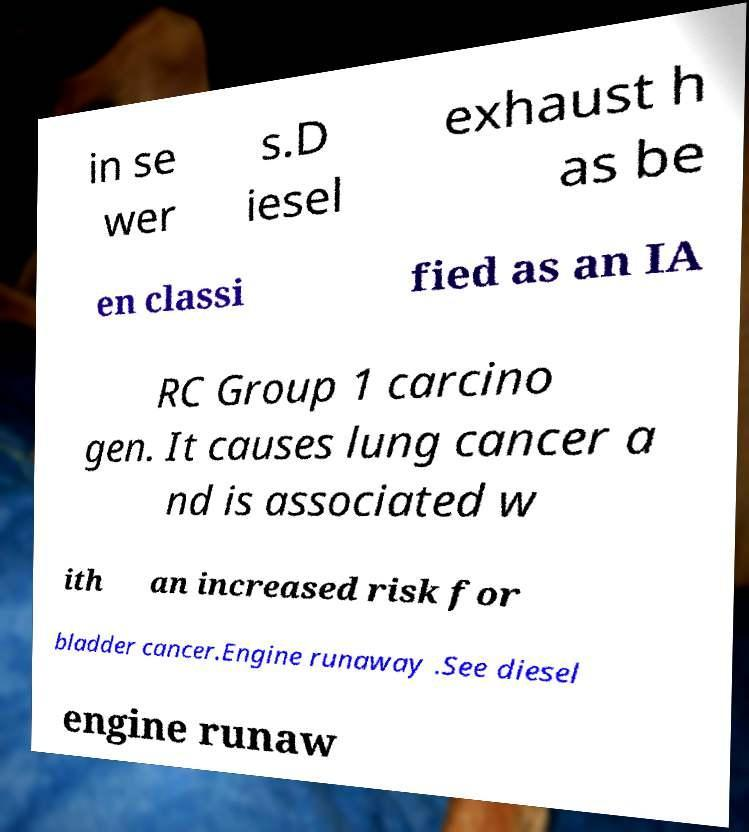Could you assist in decoding the text presented in this image and type it out clearly? in se wer s.D iesel exhaust h as be en classi fied as an IA RC Group 1 carcino gen. It causes lung cancer a nd is associated w ith an increased risk for bladder cancer.Engine runaway .See diesel engine runaw 